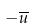<formula> <loc_0><loc_0><loc_500><loc_500>- \overline { u }</formula> 